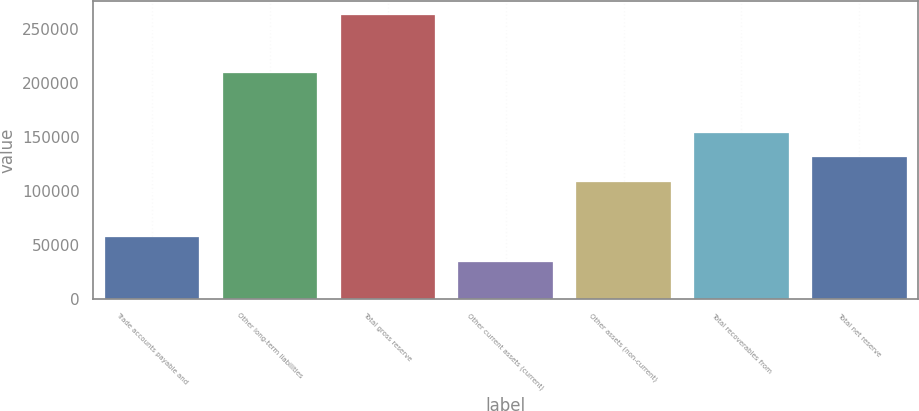Convert chart to OTSL. <chart><loc_0><loc_0><loc_500><loc_500><bar_chart><fcel>Trade accounts payable and<fcel>Other long-term liabilities<fcel>Total gross reserve<fcel>Other current assets (current)<fcel>Other assets (non-current)<fcel>Total recoverables from<fcel>Total net reserve<nl><fcel>57137.3<fcel>209302<fcel>262763<fcel>34290<fcel>108305<fcel>154000<fcel>131152<nl></chart> 